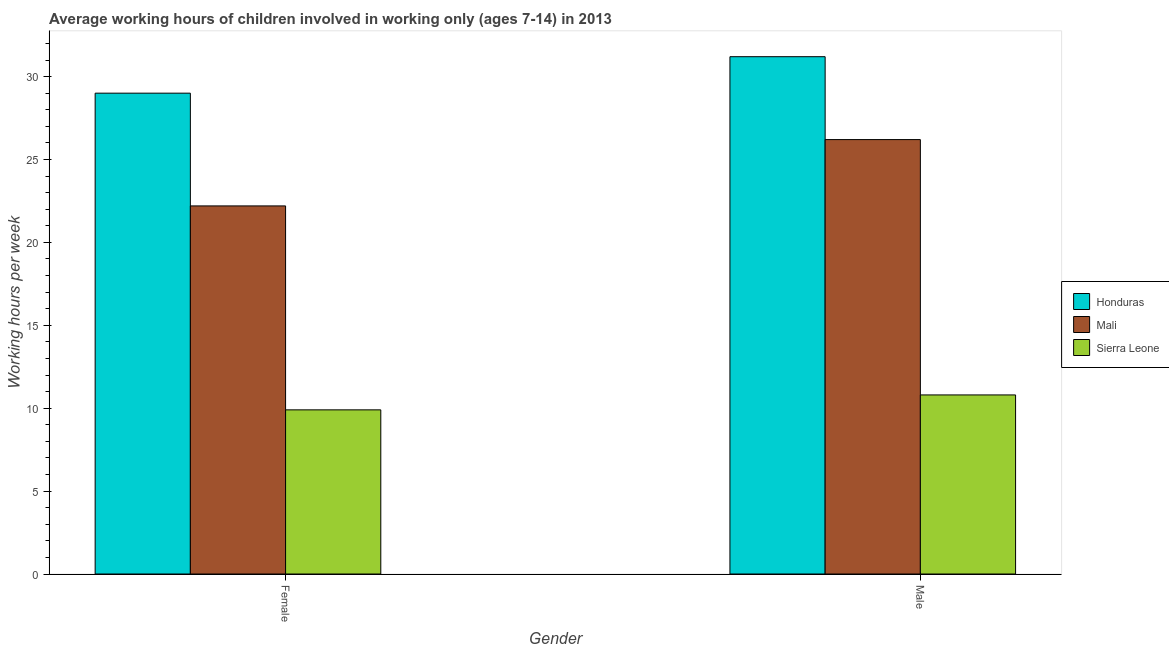How many different coloured bars are there?
Provide a succinct answer. 3. Are the number of bars per tick equal to the number of legend labels?
Ensure brevity in your answer.  Yes. Are the number of bars on each tick of the X-axis equal?
Offer a very short reply. Yes. How many bars are there on the 2nd tick from the left?
Make the answer very short. 3. How many bars are there on the 2nd tick from the right?
Keep it short and to the point. 3. What is the label of the 2nd group of bars from the left?
Your answer should be compact. Male. Across all countries, what is the maximum average working hour of female children?
Offer a very short reply. 29. In which country was the average working hour of female children maximum?
Provide a succinct answer. Honduras. In which country was the average working hour of female children minimum?
Your answer should be compact. Sierra Leone. What is the total average working hour of female children in the graph?
Provide a succinct answer. 61.1. What is the difference between the average working hour of female children in Mali and that in Sierra Leone?
Offer a terse response. 12.3. What is the difference between the average working hour of male children in Mali and the average working hour of female children in Sierra Leone?
Your answer should be very brief. 16.3. What is the average average working hour of female children per country?
Provide a succinct answer. 20.37. What is the difference between the average working hour of female children and average working hour of male children in Mali?
Your answer should be very brief. -4. What is the ratio of the average working hour of male children in Sierra Leone to that in Honduras?
Your response must be concise. 0.35. In how many countries, is the average working hour of female children greater than the average average working hour of female children taken over all countries?
Ensure brevity in your answer.  2. What does the 1st bar from the left in Female represents?
Your answer should be very brief. Honduras. What does the 1st bar from the right in Female represents?
Keep it short and to the point. Sierra Leone. How many bars are there?
Ensure brevity in your answer.  6. Are all the bars in the graph horizontal?
Ensure brevity in your answer.  No. How many countries are there in the graph?
Keep it short and to the point. 3. What is the difference between two consecutive major ticks on the Y-axis?
Offer a terse response. 5. Does the graph contain any zero values?
Give a very brief answer. No. Does the graph contain grids?
Provide a succinct answer. No. How many legend labels are there?
Your answer should be very brief. 3. What is the title of the graph?
Your response must be concise. Average working hours of children involved in working only (ages 7-14) in 2013. Does "St. Martin (French part)" appear as one of the legend labels in the graph?
Keep it short and to the point. No. What is the label or title of the X-axis?
Make the answer very short. Gender. What is the label or title of the Y-axis?
Your response must be concise. Working hours per week. What is the Working hours per week in Honduras in Female?
Your response must be concise. 29. What is the Working hours per week of Honduras in Male?
Ensure brevity in your answer.  31.2. What is the Working hours per week in Mali in Male?
Keep it short and to the point. 26.2. Across all Gender, what is the maximum Working hours per week of Honduras?
Your answer should be compact. 31.2. Across all Gender, what is the maximum Working hours per week of Mali?
Offer a very short reply. 26.2. Across all Gender, what is the maximum Working hours per week of Sierra Leone?
Your answer should be very brief. 10.8. What is the total Working hours per week of Honduras in the graph?
Your response must be concise. 60.2. What is the total Working hours per week of Mali in the graph?
Ensure brevity in your answer.  48.4. What is the total Working hours per week in Sierra Leone in the graph?
Offer a very short reply. 20.7. What is the difference between the Working hours per week of Sierra Leone in Female and that in Male?
Your response must be concise. -0.9. What is the difference between the Working hours per week of Honduras in Female and the Working hours per week of Sierra Leone in Male?
Your answer should be very brief. 18.2. What is the average Working hours per week of Honduras per Gender?
Offer a terse response. 30.1. What is the average Working hours per week in Mali per Gender?
Your answer should be compact. 24.2. What is the average Working hours per week of Sierra Leone per Gender?
Your response must be concise. 10.35. What is the difference between the Working hours per week of Honduras and Working hours per week of Sierra Leone in Female?
Provide a short and direct response. 19.1. What is the difference between the Working hours per week of Honduras and Working hours per week of Mali in Male?
Provide a succinct answer. 5. What is the difference between the Working hours per week of Honduras and Working hours per week of Sierra Leone in Male?
Offer a very short reply. 20.4. What is the ratio of the Working hours per week of Honduras in Female to that in Male?
Keep it short and to the point. 0.93. What is the ratio of the Working hours per week in Mali in Female to that in Male?
Ensure brevity in your answer.  0.85. What is the difference between the highest and the second highest Working hours per week of Honduras?
Offer a very short reply. 2.2. What is the difference between the highest and the second highest Working hours per week of Mali?
Keep it short and to the point. 4. What is the difference between the highest and the second highest Working hours per week of Sierra Leone?
Keep it short and to the point. 0.9. 